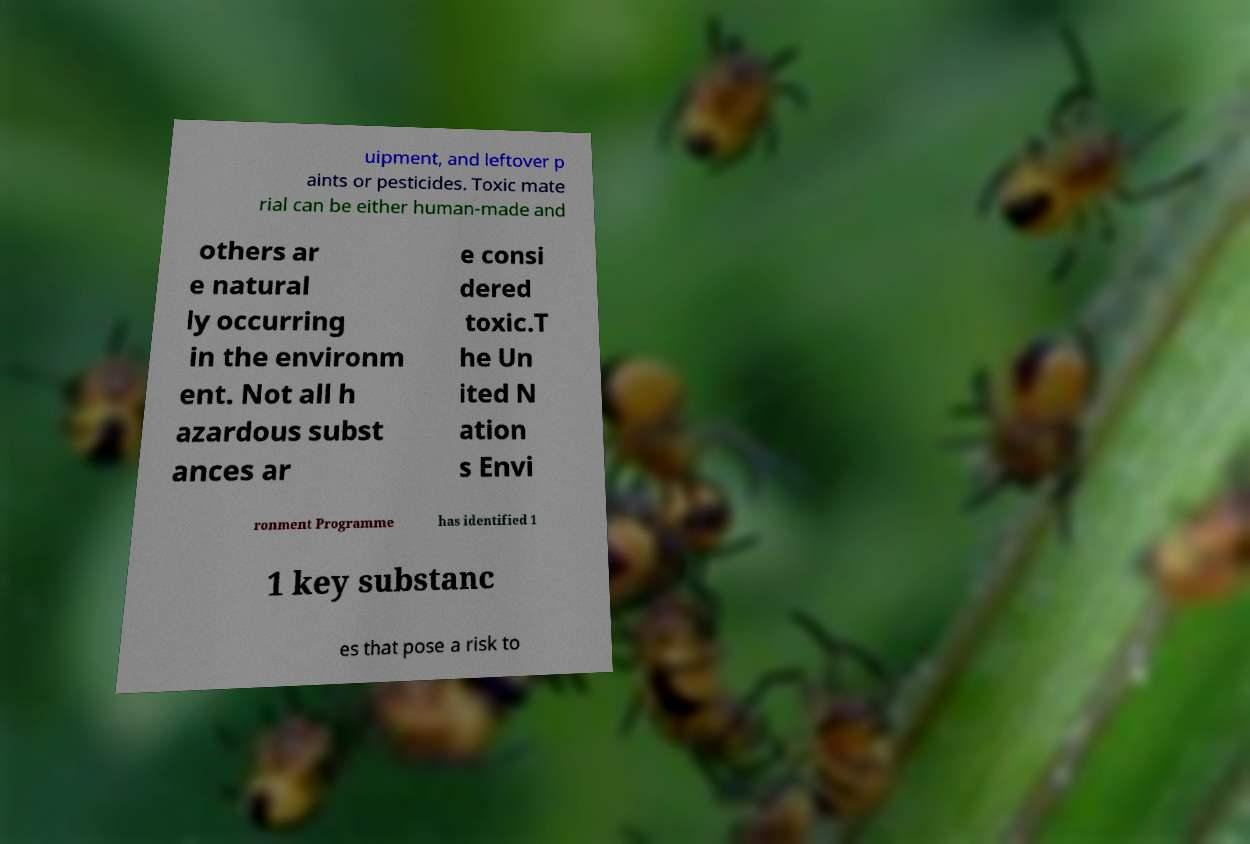Could you extract and type out the text from this image? uipment, and leftover p aints or pesticides. Toxic mate rial can be either human-made and others ar e natural ly occurring in the environm ent. Not all h azardous subst ances ar e consi dered toxic.T he Un ited N ation s Envi ronment Programme has identified 1 1 key substanc es that pose a risk to 